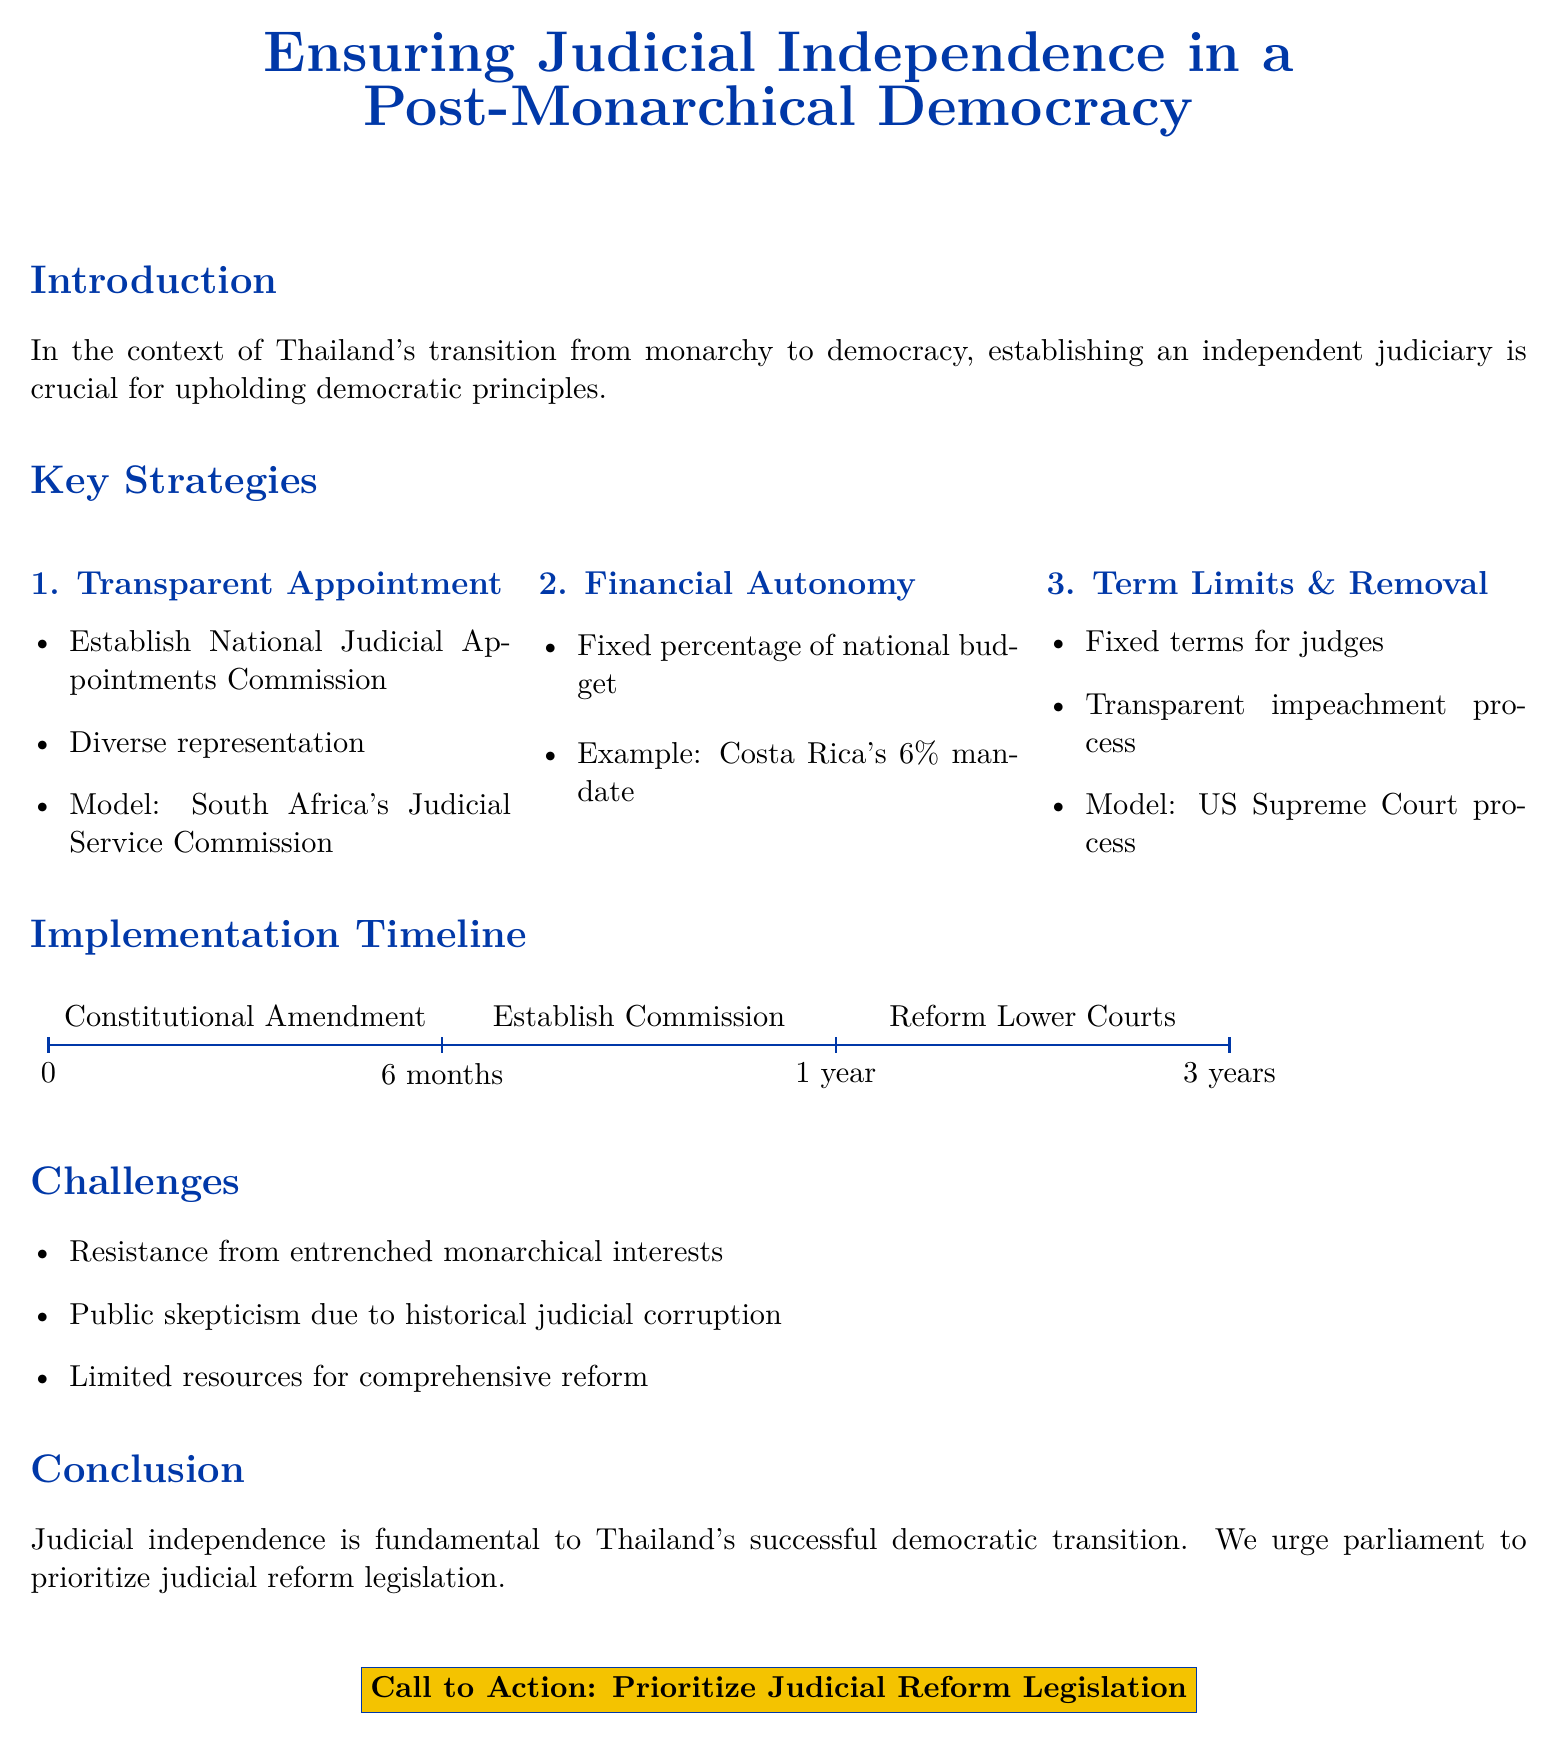What is the title of the document? The title is prominently displayed at the top of the document and encapsulates its main focus.
Answer: Ensuring Judicial Independence in a Post-Monarchical Democracy What is the first key strategy outlined in the document? The first key strategy is listed in a numbered format in the Key Strategies section.
Answer: Transparent Appointment What percentage of the national budget is mentioned for financial autonomy? This information is included under the Financial Autonomy subsection as an example.
Answer: 6% What is the proposed implementation time for establishing the Commission? The specific timeline for this step is visually represented in the Implementation Timeline section.
Answer: 6 months What is one major challenge mentioned in the document? A list of challenges is provided, highlighting obstacles to judicial reform.
Answer: Resistance from entrenched monarchical interests What reform model is referenced for the transparent appointment of judges? This model is provided as an example in the first key strategy.
Answer: South Africa's Judicial Service Commission How many total strategies are outlined in the document? The number of strategies can be counted in the Key Strategies section.
Answer: Three What is the call to action at the end of the document? This is a bolded statement that emphasizes the main recommendation presented in the conclusion.
Answer: Prioritize Judicial Reform Legislation 